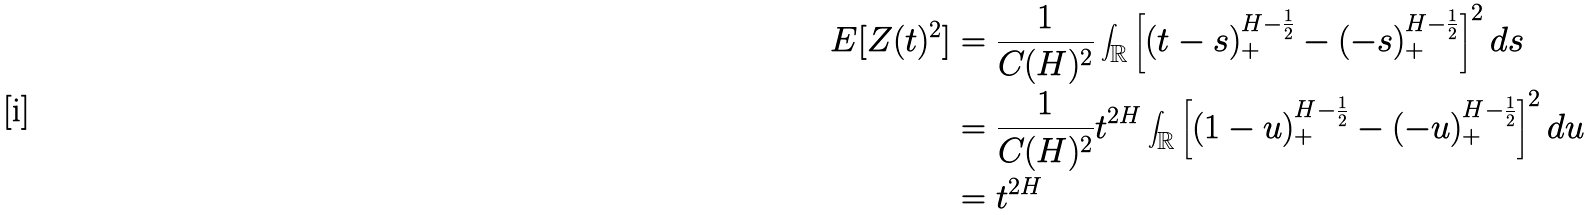Convert formula to latex. <formula><loc_0><loc_0><loc_500><loc_500>E [ Z ( t ) ^ { 2 } ] & = \frac { 1 } { C ( H ) ^ { 2 } } \int _ { \mathbb { R } } \left [ ( t - s ) ^ { H - \frac { 1 } { 2 } } _ { + } - ( - s ) ^ { H - \frac { 1 } { 2 } } _ { + } \right ] ^ { 2 } d s \\ & = \frac { 1 } { C ( H ) ^ { 2 } } t ^ { 2 H } \int _ { \mathbb { R } } \left [ ( 1 - u ) ^ { H - \frac { 1 } { 2 } } _ { + } - ( - u ) ^ { H - \frac { 1 } { 2 } } _ { + } \right ] ^ { 2 } d u \\ & = t ^ { 2 H }</formula> 